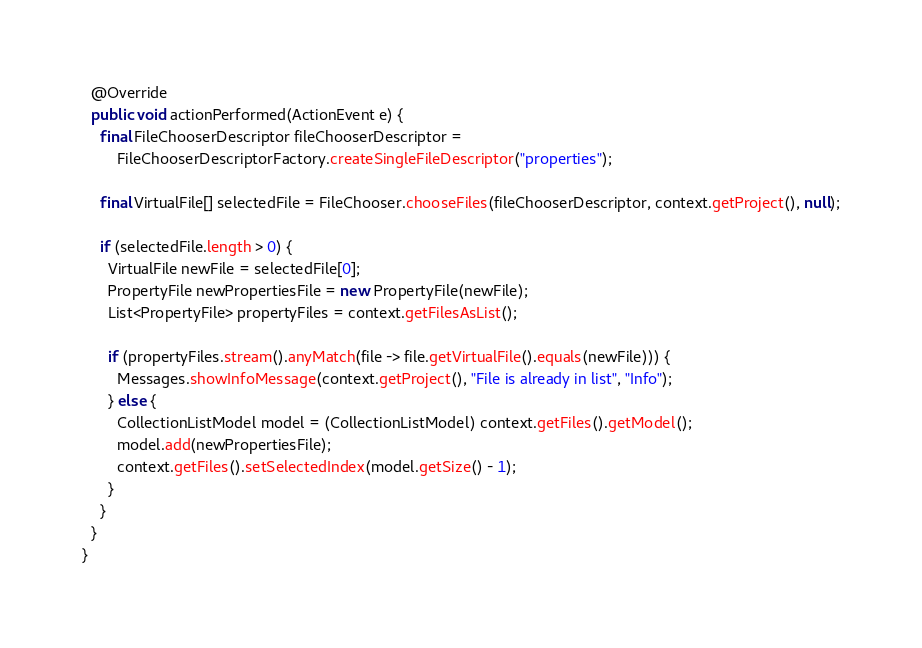<code> <loc_0><loc_0><loc_500><loc_500><_Java_>
  @Override
  public void actionPerformed(ActionEvent e) {
    final FileChooserDescriptor fileChooserDescriptor =
        FileChooserDescriptorFactory.createSingleFileDescriptor("properties");

    final VirtualFile[] selectedFile = FileChooser.chooseFiles(fileChooserDescriptor, context.getProject(), null);

    if (selectedFile.length > 0) {
      VirtualFile newFile = selectedFile[0];
      PropertyFile newPropertiesFile = new PropertyFile(newFile);
      List<PropertyFile> propertyFiles = context.getFilesAsList();

      if (propertyFiles.stream().anyMatch(file -> file.getVirtualFile().equals(newFile))) {
        Messages.showInfoMessage(context.getProject(), "File is already in list", "Info");
      } else {
        CollectionListModel model = (CollectionListModel) context.getFiles().getModel();
        model.add(newPropertiesFile);
        context.getFiles().setSelectedIndex(model.getSize() - 1);
      }
    }
  }
}
</code> 